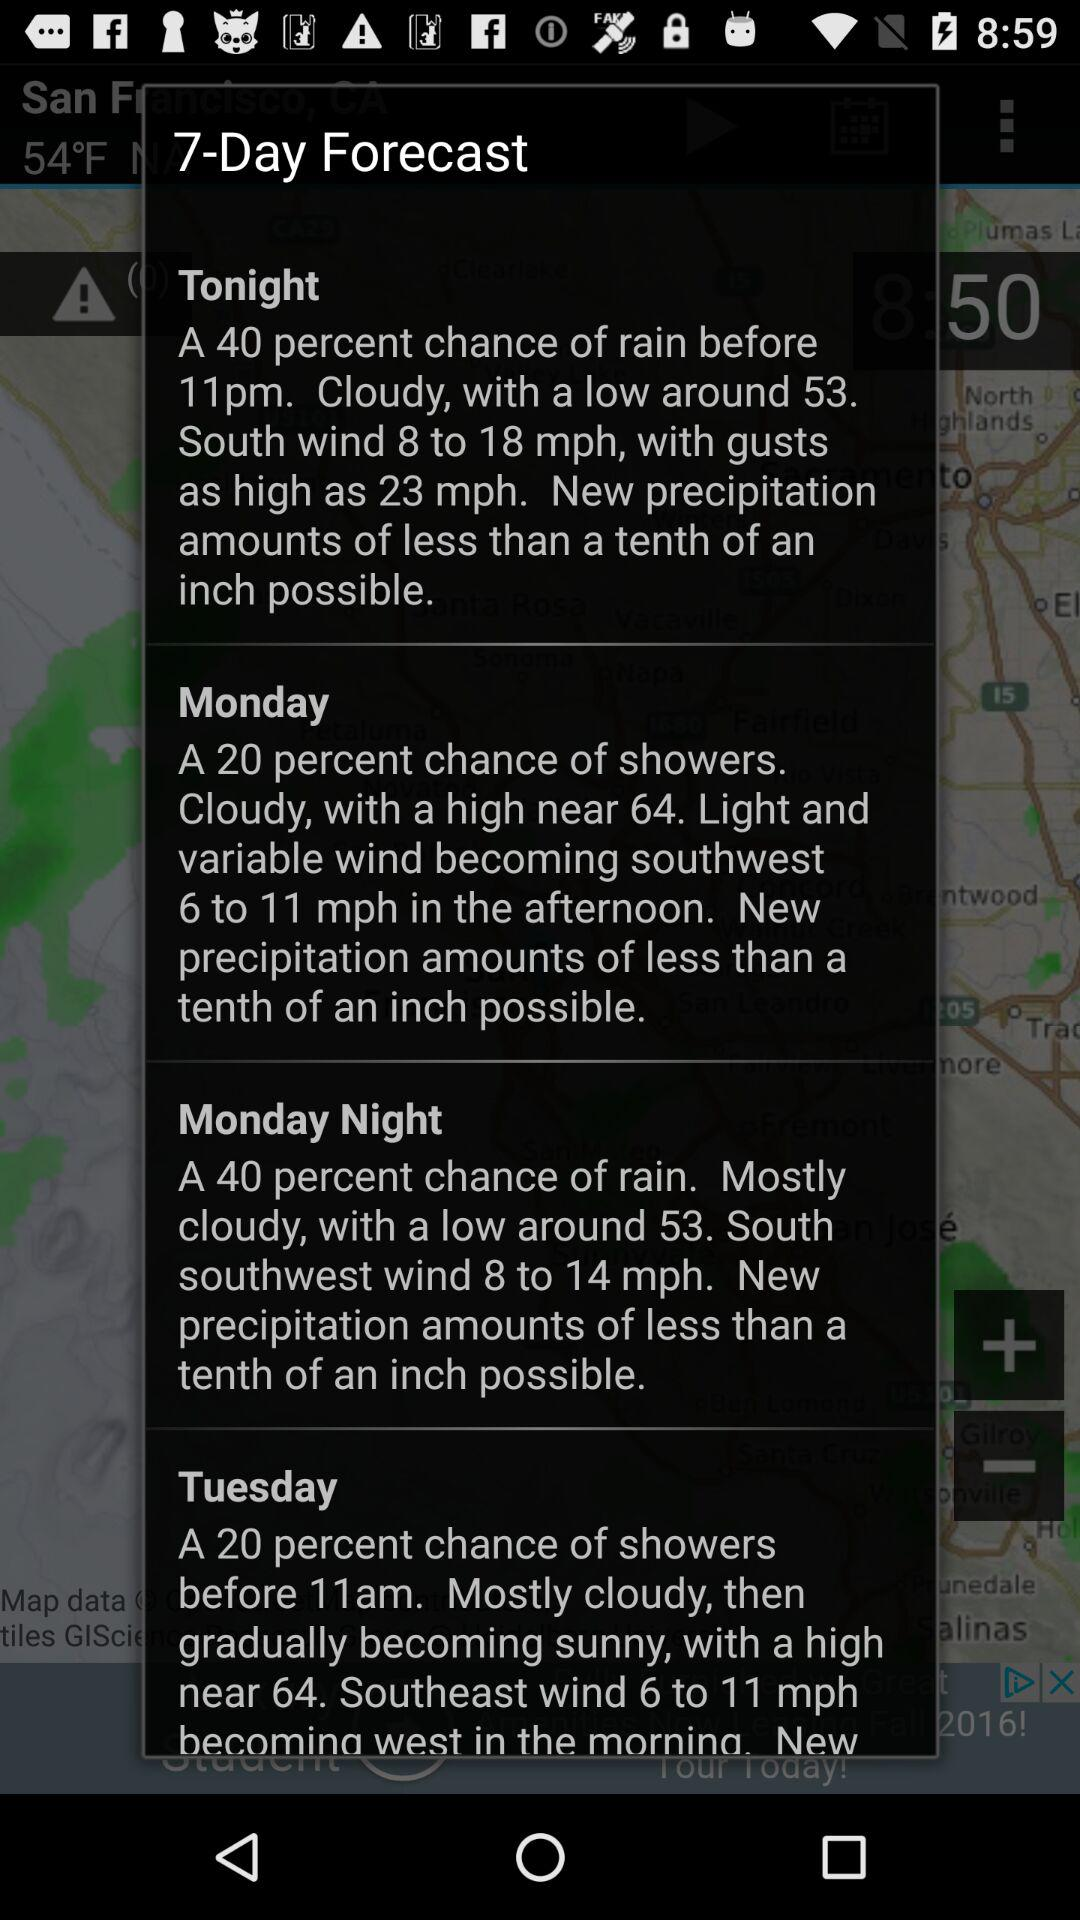How much precipitation will there be on Wednesday?
When the provided information is insufficient, respond with <no answer>. <no answer> 